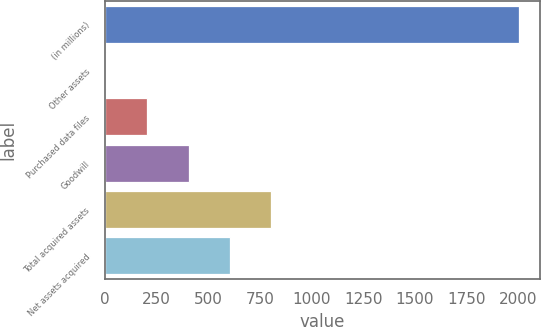Convert chart to OTSL. <chart><loc_0><loc_0><loc_500><loc_500><bar_chart><fcel>(in millions)<fcel>Other assets<fcel>Purchased data files<fcel>Goodwill<fcel>Total acquired assets<fcel>Net assets acquired<nl><fcel>2003<fcel>5.9<fcel>205.61<fcel>405.32<fcel>804.74<fcel>605.03<nl></chart> 